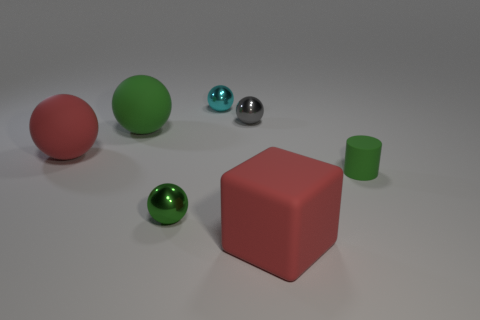Subtract all tiny cyan spheres. How many spheres are left? 4 Add 3 blue metal blocks. How many objects exist? 10 Subtract all brown blocks. How many green balls are left? 2 Subtract all cyan balls. How many balls are left? 4 Subtract 3 spheres. How many spheres are left? 2 Subtract all red balls. Subtract all cyan cubes. How many balls are left? 4 Subtract all big gray things. Subtract all tiny green spheres. How many objects are left? 6 Add 4 small gray metal balls. How many small gray metal balls are left? 5 Add 2 large red spheres. How many large red spheres exist? 3 Subtract 0 yellow spheres. How many objects are left? 7 